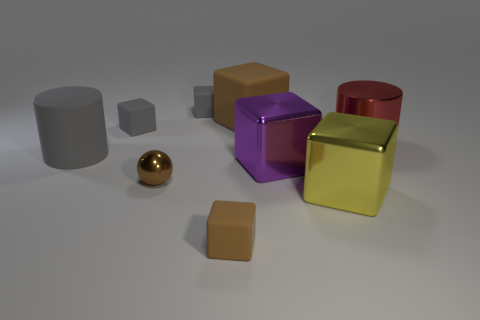What number of tiny things are brown shiny spheres or red metallic spheres?
Give a very brief answer. 1. Do the sphere that is left of the red metallic object and the big rubber block have the same color?
Offer a very short reply. Yes. Is the color of the large shiny block to the left of the yellow cube the same as the matte block in front of the big purple metallic block?
Your answer should be compact. No. Is there a tiny object that has the same material as the purple block?
Your response must be concise. Yes. What number of green things are either large rubber blocks or cylinders?
Your answer should be very brief. 0. Is the number of big matte things behind the big red shiny object greater than the number of cylinders?
Provide a short and direct response. No. Do the sphere and the yellow thing have the same size?
Offer a terse response. No. What color is the ball that is made of the same material as the large purple block?
Keep it short and to the point. Brown. What is the shape of the tiny thing that is the same color as the small metal ball?
Provide a succinct answer. Cube. Are there the same number of large gray matte cylinders on the right side of the big yellow shiny thing and purple metal objects to the right of the large purple thing?
Make the answer very short. Yes. 